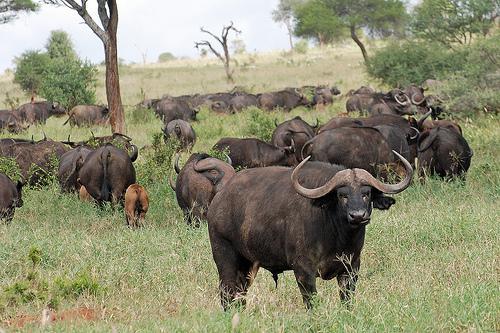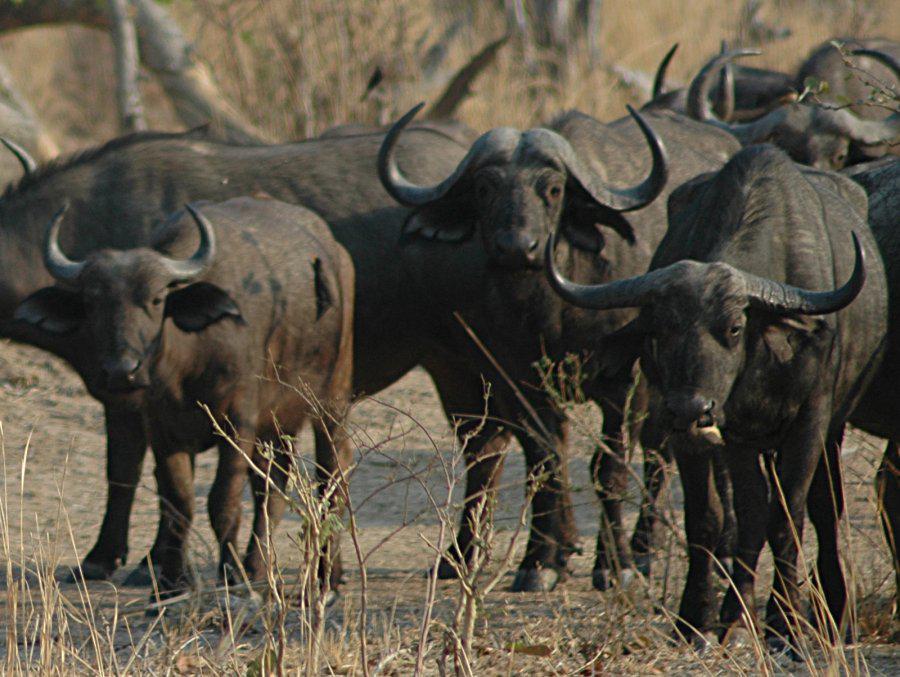The first image is the image on the left, the second image is the image on the right. Evaluate the accuracy of this statement regarding the images: "Both images contains an easily visible group of buffalo with at least one facing forward and no water.". Is it true? Answer yes or no. Yes. The first image is the image on the left, the second image is the image on the right. Analyze the images presented: Is the assertion "In one image, most of the water buffalo stand with their rears turned toward the camera." valid? Answer yes or no. Yes. 